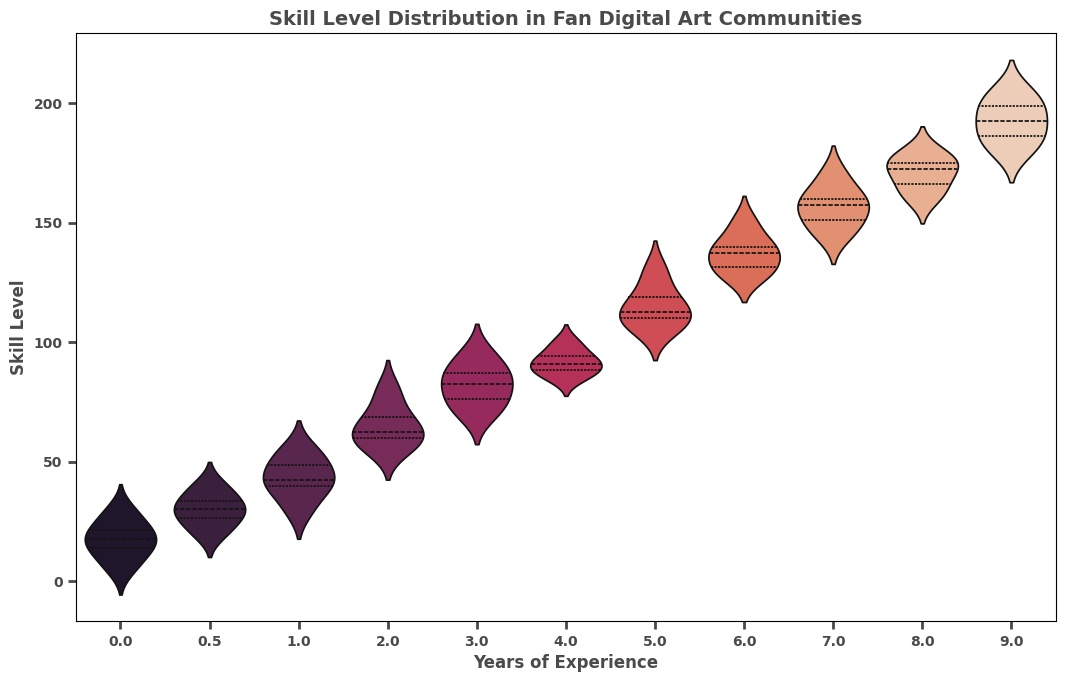What is the median skill level for artists with 6 years of experience? To find the median skill level for artists with 6 years of experience, we list the skill levels in order: 128, 130, 135, 140, 140, 150. The median is the middle value, but since there is an even number of data points, we take the average of the two middle values: (135 + 140) / 2 = 137.5
Answer: 137.5 Which experience level has the widest range in skill levels? To find the widest range, we look at each group and calculate the range (max - min skill level). 9 years has a range from 180 to 205, which is 205 - 180 = 25. This is the largest range in skill levels among the groups.
Answer: 9 years of experience Do artists with no experience have a higher or lower median skill level compared to those with 1 year of experience? The median skill level for artists with no experience can be found by listing the skill levels: 5, 10, 15, 15, 20, 20, 25, 30. The median is the average of the two middle values: (15 + 15) / 2 = 15. The skill levels for 1 year of experience are 30, 40, 40, 45, 50, 55, with the median being (40 + 40) / 2 = 40. Thus, artists with no experience have a lower median skill level compared to those with 1 year of experience.
Answer: Lower How does the interquartile range (IQR) of skill levels for artists with 8 years of experience compare to those with 7 years? For 8 years of experience, the skill levels are 160, 165, 170, 175, 175, 180. The IQR is the 75th percentile value minus the 25th percentile value: (175 - 165) = 10. For 7 years of experience, the skill levels are 145, 150, 150, 155, 160, 160, 170. The IQR is (160 - 150) = 10. Therefore, both groups have the same IQR.
Answer: Same What is the mode skill level for artists with 9 years of experience? To find the mode, we look for the skill level that appears most frequently in the group with 9 years of experience. The skill levels are 180, 185, 190, 195, 200, 205. Each level appears exactly once, so there is no mode.
Answer: No mode Is there a noticeable trend in skill level as years of experience increase? By examining the spread and central tendency of skill levels across different years of experience, we observe that as years of experience increase, skill levels generally increase as well. This is indicated by higher median and more spread-out skill levels in groups with more years of experience.
Answer: Yes, skill levels generally increase with more experience 